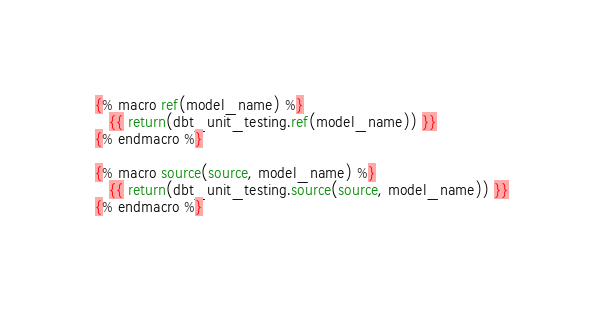Convert code to text. <code><loc_0><loc_0><loc_500><loc_500><_SQL_>{% macro ref(model_name) %}
   {{ return(dbt_unit_testing.ref(model_name)) }}
{% endmacro %}

{% macro source(source, model_name) %}
   {{ return(dbt_unit_testing.source(source, model_name)) }}
{% endmacro %}</code> 